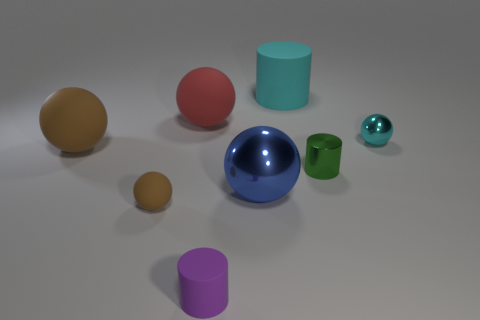Subtract all red spheres. How many spheres are left? 4 Subtract all tiny metal balls. How many balls are left? 4 Subtract all purple balls. Subtract all brown cylinders. How many balls are left? 5 Add 1 large brown rubber blocks. How many objects exist? 9 Subtract all cylinders. How many objects are left? 5 Add 7 small matte cylinders. How many small matte cylinders are left? 8 Add 6 large brown things. How many large brown things exist? 7 Subtract 0 brown cylinders. How many objects are left? 8 Subtract all big matte things. Subtract all small purple rubber cylinders. How many objects are left? 4 